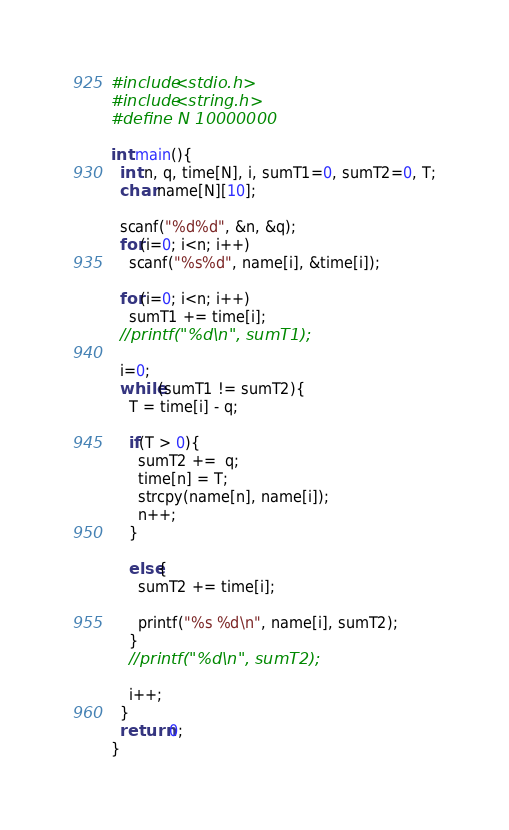<code> <loc_0><loc_0><loc_500><loc_500><_C_>#include<stdio.h>
#include<string.h>
#define N 10000000

int main(){
  int n, q, time[N], i, sumT1=0, sumT2=0, T;
  char name[N][10];
  
  scanf("%d%d", &n, &q);
  for(i=0; i<n; i++)
    scanf("%s%d", name[i], &time[i]);

  for(i=0; i<n; i++)
    sumT1 += time[i];
  //printf("%d\n", sumT1);
    
  i=0;
  while(sumT1 != sumT2){
    T = time[i] - q;
    
    if(T > 0){
      sumT2 +=  q;
      time[n] = T;
      strcpy(name[n], name[i]);
      n++;
    }

    else{
      sumT2 += time[i];

      printf("%s %d\n", name[i], sumT2);   
    }
    //printf("%d\n", sumT2);
    
    i++;
  }
  return 0;
}

</code> 